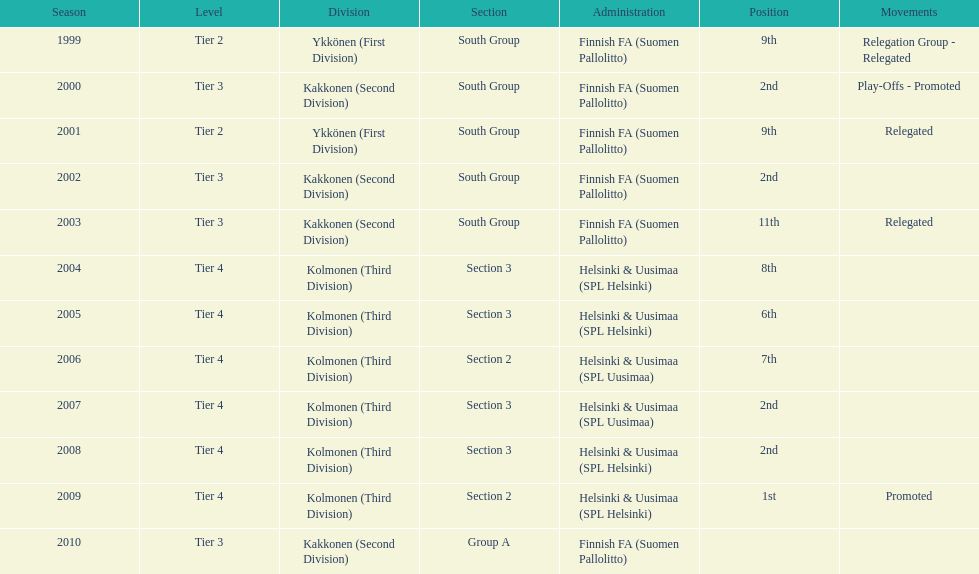In the third division, what was the number of individuals in section 3? 4. 